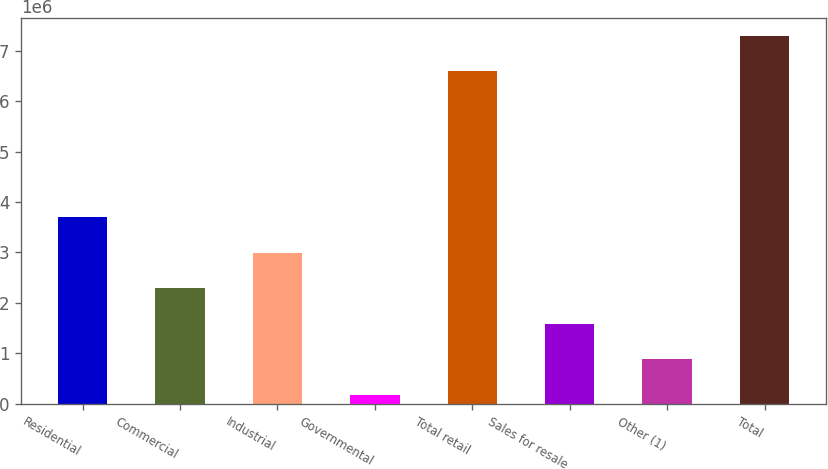Convert chart to OTSL. <chart><loc_0><loc_0><loc_500><loc_500><bar_chart><fcel>Residential<fcel>Commercial<fcel>Industrial<fcel>Governmental<fcel>Total retail<fcel>Sales for resale<fcel>Other (1)<fcel>Total<nl><fcel>3.70249e+06<fcel>2.29561e+06<fcel>2.99905e+06<fcel>185286<fcel>6.58675e+06<fcel>1.59217e+06<fcel>888726<fcel>7.29019e+06<nl></chart> 